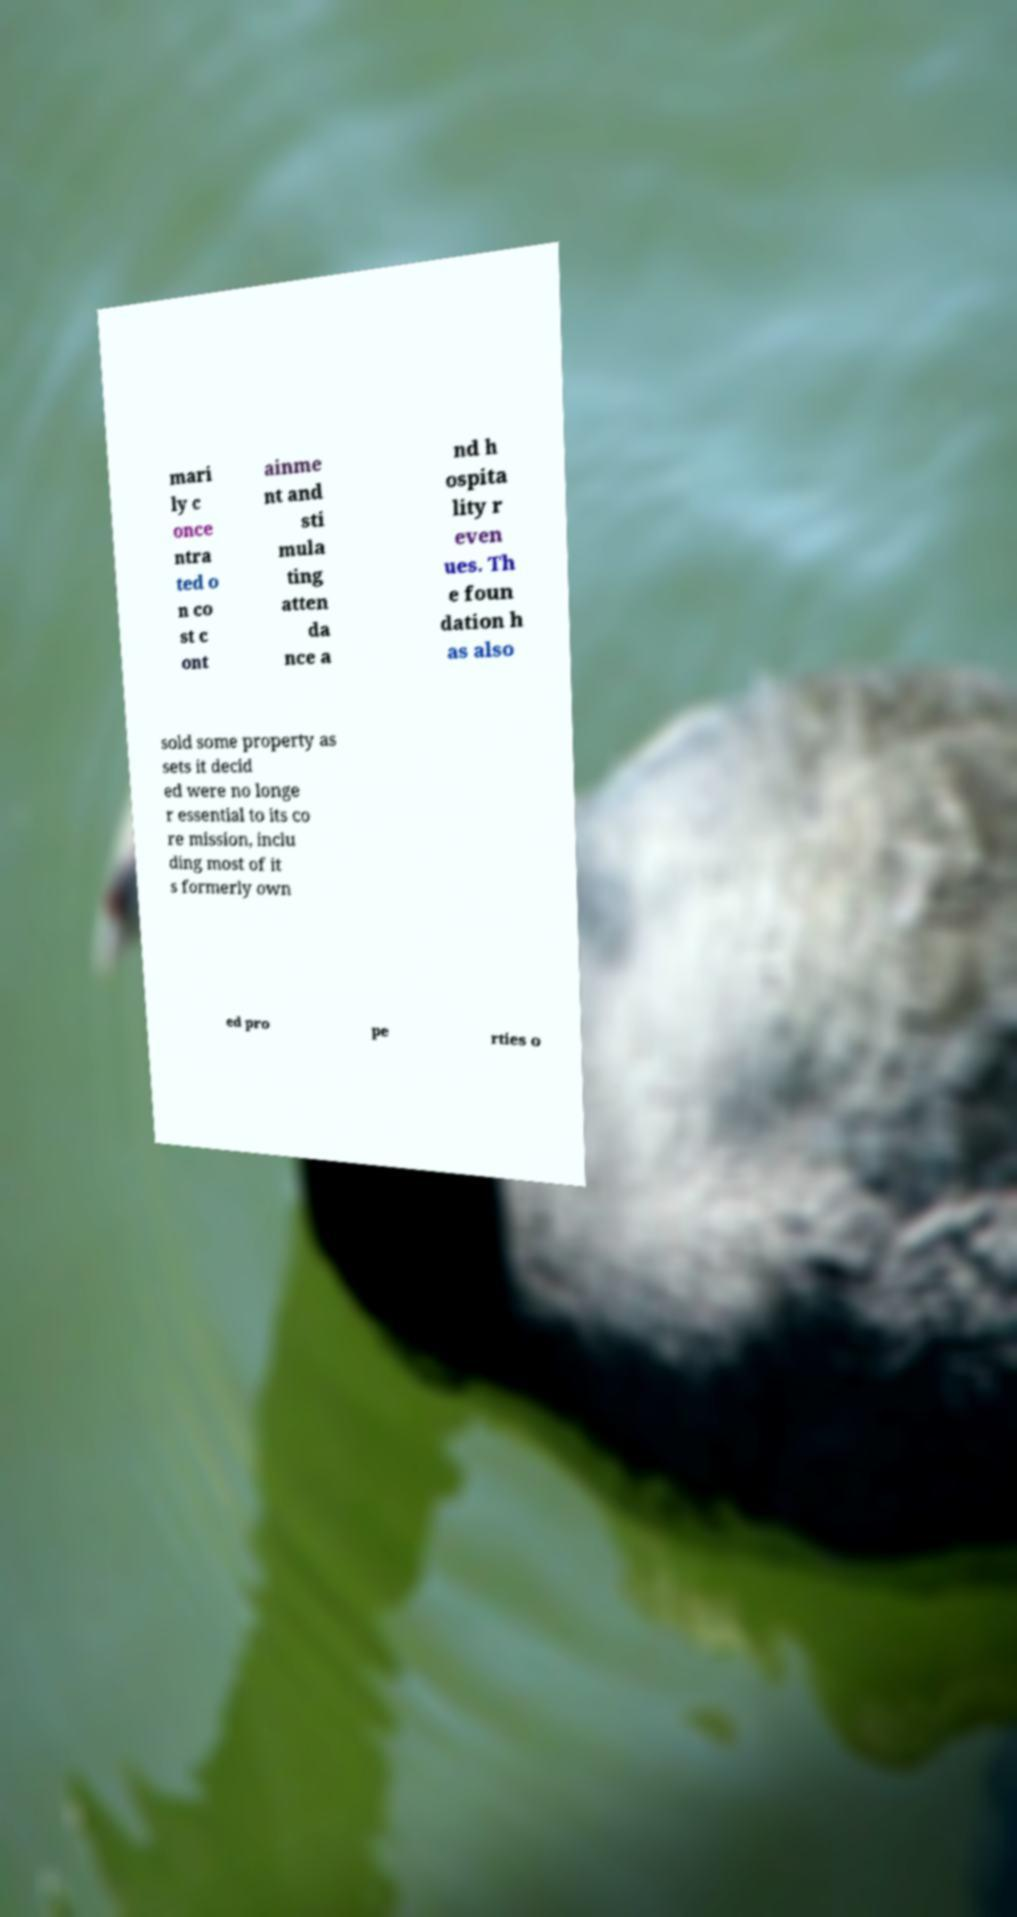For documentation purposes, I need the text within this image transcribed. Could you provide that? mari ly c once ntra ted o n co st c ont ainme nt and sti mula ting atten da nce a nd h ospita lity r even ues. Th e foun dation h as also sold some property as sets it decid ed were no longe r essential to its co re mission, inclu ding most of it s formerly own ed pro pe rties o 